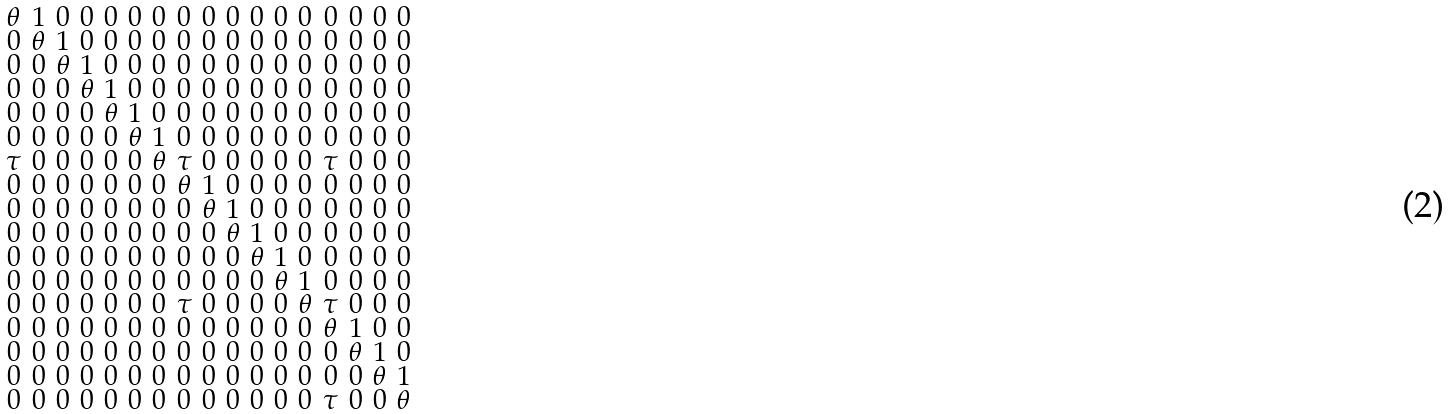Convert formula to latex. <formula><loc_0><loc_0><loc_500><loc_500>\begin{smallmatrix} \theta & 1 & 0 & 0 & 0 & 0 & 0 & 0 & 0 & 0 & 0 & 0 & 0 & 0 & 0 & 0 & 0 \\ 0 & \theta & 1 & 0 & 0 & 0 & 0 & 0 & 0 & 0 & 0 & 0 & 0 & 0 & 0 & 0 & 0 \\ 0 & 0 & \theta & 1 & 0 & 0 & 0 & 0 & 0 & 0 & 0 & 0 & 0 & 0 & 0 & 0 & 0 \\ 0 & 0 & 0 & \theta & 1 & 0 & 0 & 0 & 0 & 0 & 0 & 0 & 0 & 0 & 0 & 0 & 0 \\ 0 & 0 & 0 & 0 & \theta & 1 & 0 & 0 & 0 & 0 & 0 & 0 & 0 & 0 & 0 & 0 & 0 \\ 0 & 0 & 0 & 0 & 0 & \theta & 1 & 0 & 0 & 0 & 0 & 0 & 0 & 0 & 0 & 0 & 0 \\ \tau & 0 & 0 & 0 & 0 & 0 & \theta & \tau & 0 & 0 & 0 & 0 & 0 & \tau & 0 & 0 & 0 \\ 0 & 0 & 0 & 0 & 0 & 0 & 0 & \theta & 1 & 0 & 0 & 0 & 0 & 0 & 0 & 0 & 0 \\ 0 & 0 & 0 & 0 & 0 & 0 & 0 & 0 & \theta & 1 & 0 & 0 & 0 & 0 & 0 & 0 & 0 \\ 0 & 0 & 0 & 0 & 0 & 0 & 0 & 0 & 0 & \theta & 1 & 0 & 0 & 0 & 0 & 0 & 0 \\ 0 & 0 & 0 & 0 & 0 & 0 & 0 & 0 & 0 & 0 & \theta & 1 & 0 & 0 & 0 & 0 & 0 \\ 0 & 0 & 0 & 0 & 0 & 0 & 0 & 0 & 0 & 0 & 0 & \theta & 1 & 0 & 0 & 0 & 0 \\ 0 & 0 & 0 & 0 & 0 & 0 & 0 & \tau & 0 & 0 & 0 & 0 & \theta & \tau & 0 & 0 & 0 \\ 0 & 0 & 0 & 0 & 0 & 0 & 0 & 0 & 0 & 0 & 0 & 0 & 0 & \theta & 1 & 0 & 0 \\ 0 & 0 & 0 & 0 & 0 & 0 & 0 & 0 & 0 & 0 & 0 & 0 & 0 & 0 & \theta & 1 & 0 \\ 0 & 0 & 0 & 0 & 0 & 0 & 0 & 0 & 0 & 0 & 0 & 0 & 0 & 0 & 0 & \theta & 1 \\ 0 & 0 & 0 & 0 & 0 & 0 & 0 & 0 & 0 & 0 & 0 & 0 & 0 & \tau & 0 & 0 & \theta \\ \end{smallmatrix}</formula> 